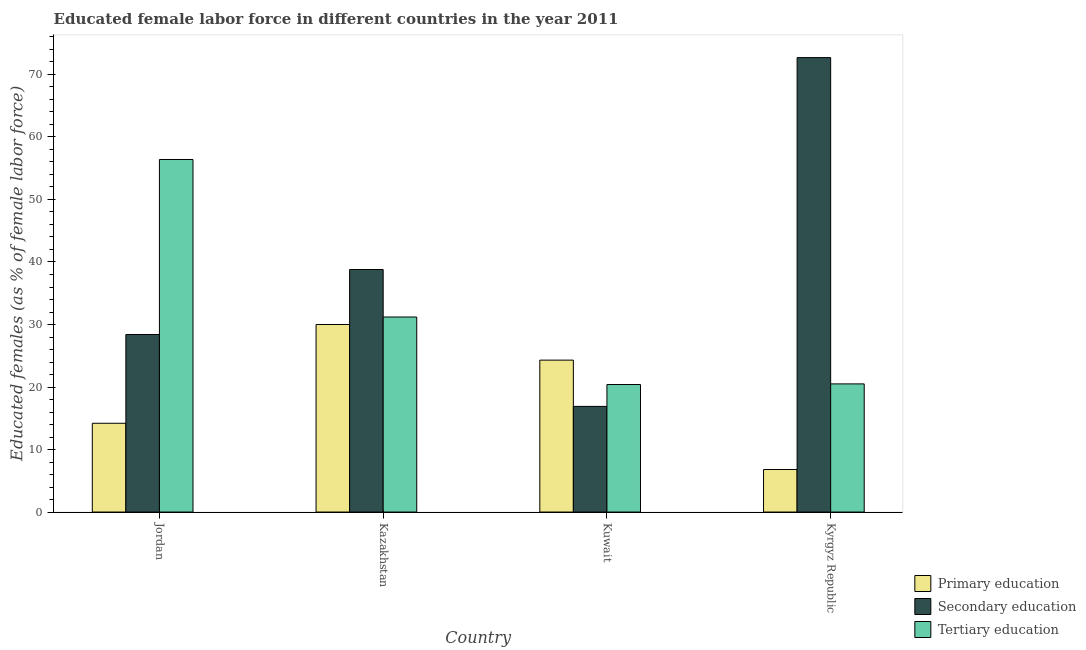How many groups of bars are there?
Keep it short and to the point. 4. Are the number of bars per tick equal to the number of legend labels?
Your answer should be very brief. Yes. How many bars are there on the 3rd tick from the left?
Keep it short and to the point. 3. What is the label of the 3rd group of bars from the left?
Provide a succinct answer. Kuwait. In how many cases, is the number of bars for a given country not equal to the number of legend labels?
Your response must be concise. 0. What is the percentage of female labor force who received secondary education in Kuwait?
Ensure brevity in your answer.  16.9. Across all countries, what is the maximum percentage of female labor force who received tertiary education?
Offer a very short reply. 56.4. Across all countries, what is the minimum percentage of female labor force who received secondary education?
Your answer should be compact. 16.9. In which country was the percentage of female labor force who received primary education maximum?
Provide a succinct answer. Kazakhstan. In which country was the percentage of female labor force who received secondary education minimum?
Offer a terse response. Kuwait. What is the total percentage of female labor force who received primary education in the graph?
Ensure brevity in your answer.  75.3. What is the difference between the percentage of female labor force who received tertiary education in Kazakhstan and that in Kyrgyz Republic?
Give a very brief answer. 10.7. What is the difference between the percentage of female labor force who received secondary education in Kyrgyz Republic and the percentage of female labor force who received tertiary education in Jordan?
Offer a terse response. 16.3. What is the average percentage of female labor force who received tertiary education per country?
Provide a short and direct response. 32.13. What is the difference between the percentage of female labor force who received primary education and percentage of female labor force who received tertiary education in Kuwait?
Provide a short and direct response. 3.9. What is the ratio of the percentage of female labor force who received primary education in Kuwait to that in Kyrgyz Republic?
Make the answer very short. 3.57. Is the percentage of female labor force who received primary education in Kuwait less than that in Kyrgyz Republic?
Ensure brevity in your answer.  No. What is the difference between the highest and the second highest percentage of female labor force who received secondary education?
Your response must be concise. 33.9. What is the difference between the highest and the lowest percentage of female labor force who received primary education?
Make the answer very short. 23.2. What does the 2nd bar from the left in Kyrgyz Republic represents?
Make the answer very short. Secondary education. What does the 2nd bar from the right in Kyrgyz Republic represents?
Offer a terse response. Secondary education. What is the difference between two consecutive major ticks on the Y-axis?
Give a very brief answer. 10. Are the values on the major ticks of Y-axis written in scientific E-notation?
Provide a succinct answer. No. Does the graph contain any zero values?
Your response must be concise. No. Where does the legend appear in the graph?
Provide a succinct answer. Bottom right. How many legend labels are there?
Keep it short and to the point. 3. What is the title of the graph?
Provide a succinct answer. Educated female labor force in different countries in the year 2011. What is the label or title of the X-axis?
Keep it short and to the point. Country. What is the label or title of the Y-axis?
Give a very brief answer. Educated females (as % of female labor force). What is the Educated females (as % of female labor force) of Primary education in Jordan?
Your response must be concise. 14.2. What is the Educated females (as % of female labor force) of Secondary education in Jordan?
Give a very brief answer. 28.4. What is the Educated females (as % of female labor force) of Tertiary education in Jordan?
Provide a short and direct response. 56.4. What is the Educated females (as % of female labor force) of Primary education in Kazakhstan?
Offer a very short reply. 30. What is the Educated females (as % of female labor force) of Secondary education in Kazakhstan?
Ensure brevity in your answer.  38.8. What is the Educated females (as % of female labor force) in Tertiary education in Kazakhstan?
Your response must be concise. 31.2. What is the Educated females (as % of female labor force) in Primary education in Kuwait?
Your response must be concise. 24.3. What is the Educated females (as % of female labor force) in Secondary education in Kuwait?
Make the answer very short. 16.9. What is the Educated females (as % of female labor force) of Tertiary education in Kuwait?
Offer a very short reply. 20.4. What is the Educated females (as % of female labor force) of Primary education in Kyrgyz Republic?
Offer a terse response. 6.8. What is the Educated females (as % of female labor force) in Secondary education in Kyrgyz Republic?
Ensure brevity in your answer.  72.7. Across all countries, what is the maximum Educated females (as % of female labor force) of Primary education?
Give a very brief answer. 30. Across all countries, what is the maximum Educated females (as % of female labor force) of Secondary education?
Your answer should be compact. 72.7. Across all countries, what is the maximum Educated females (as % of female labor force) in Tertiary education?
Ensure brevity in your answer.  56.4. Across all countries, what is the minimum Educated females (as % of female labor force) of Primary education?
Provide a succinct answer. 6.8. Across all countries, what is the minimum Educated females (as % of female labor force) of Secondary education?
Offer a terse response. 16.9. Across all countries, what is the minimum Educated females (as % of female labor force) in Tertiary education?
Your response must be concise. 20.4. What is the total Educated females (as % of female labor force) in Primary education in the graph?
Provide a succinct answer. 75.3. What is the total Educated females (as % of female labor force) in Secondary education in the graph?
Give a very brief answer. 156.8. What is the total Educated females (as % of female labor force) in Tertiary education in the graph?
Your answer should be very brief. 128.5. What is the difference between the Educated females (as % of female labor force) of Primary education in Jordan and that in Kazakhstan?
Your answer should be compact. -15.8. What is the difference between the Educated females (as % of female labor force) of Secondary education in Jordan and that in Kazakhstan?
Provide a short and direct response. -10.4. What is the difference between the Educated females (as % of female labor force) in Tertiary education in Jordan and that in Kazakhstan?
Keep it short and to the point. 25.2. What is the difference between the Educated females (as % of female labor force) in Secondary education in Jordan and that in Kyrgyz Republic?
Make the answer very short. -44.3. What is the difference between the Educated females (as % of female labor force) in Tertiary education in Jordan and that in Kyrgyz Republic?
Offer a very short reply. 35.9. What is the difference between the Educated females (as % of female labor force) of Secondary education in Kazakhstan and that in Kuwait?
Provide a short and direct response. 21.9. What is the difference between the Educated females (as % of female labor force) of Tertiary education in Kazakhstan and that in Kuwait?
Offer a very short reply. 10.8. What is the difference between the Educated females (as % of female labor force) in Primary education in Kazakhstan and that in Kyrgyz Republic?
Give a very brief answer. 23.2. What is the difference between the Educated females (as % of female labor force) in Secondary education in Kazakhstan and that in Kyrgyz Republic?
Provide a succinct answer. -33.9. What is the difference between the Educated females (as % of female labor force) in Primary education in Kuwait and that in Kyrgyz Republic?
Your answer should be compact. 17.5. What is the difference between the Educated females (as % of female labor force) in Secondary education in Kuwait and that in Kyrgyz Republic?
Your answer should be very brief. -55.8. What is the difference between the Educated females (as % of female labor force) of Tertiary education in Kuwait and that in Kyrgyz Republic?
Provide a succinct answer. -0.1. What is the difference between the Educated females (as % of female labor force) of Primary education in Jordan and the Educated females (as % of female labor force) of Secondary education in Kazakhstan?
Ensure brevity in your answer.  -24.6. What is the difference between the Educated females (as % of female labor force) of Primary education in Jordan and the Educated females (as % of female labor force) of Tertiary education in Kazakhstan?
Your answer should be very brief. -17. What is the difference between the Educated females (as % of female labor force) of Secondary education in Jordan and the Educated females (as % of female labor force) of Tertiary education in Kazakhstan?
Make the answer very short. -2.8. What is the difference between the Educated females (as % of female labor force) of Primary education in Jordan and the Educated females (as % of female labor force) of Secondary education in Kuwait?
Your response must be concise. -2.7. What is the difference between the Educated females (as % of female labor force) in Primary education in Jordan and the Educated females (as % of female labor force) in Secondary education in Kyrgyz Republic?
Give a very brief answer. -58.5. What is the difference between the Educated females (as % of female labor force) of Primary education in Kazakhstan and the Educated females (as % of female labor force) of Secondary education in Kuwait?
Your answer should be compact. 13.1. What is the difference between the Educated females (as % of female labor force) of Secondary education in Kazakhstan and the Educated females (as % of female labor force) of Tertiary education in Kuwait?
Offer a very short reply. 18.4. What is the difference between the Educated females (as % of female labor force) of Primary education in Kazakhstan and the Educated females (as % of female labor force) of Secondary education in Kyrgyz Republic?
Offer a very short reply. -42.7. What is the difference between the Educated females (as % of female labor force) of Primary education in Kuwait and the Educated females (as % of female labor force) of Secondary education in Kyrgyz Republic?
Your answer should be compact. -48.4. What is the difference between the Educated females (as % of female labor force) of Secondary education in Kuwait and the Educated females (as % of female labor force) of Tertiary education in Kyrgyz Republic?
Offer a terse response. -3.6. What is the average Educated females (as % of female labor force) in Primary education per country?
Offer a very short reply. 18.82. What is the average Educated females (as % of female labor force) in Secondary education per country?
Keep it short and to the point. 39.2. What is the average Educated females (as % of female labor force) in Tertiary education per country?
Provide a succinct answer. 32.12. What is the difference between the Educated females (as % of female labor force) in Primary education and Educated females (as % of female labor force) in Tertiary education in Jordan?
Ensure brevity in your answer.  -42.2. What is the difference between the Educated females (as % of female labor force) of Primary education and Educated females (as % of female labor force) of Secondary education in Kazakhstan?
Give a very brief answer. -8.8. What is the difference between the Educated females (as % of female labor force) in Primary education and Educated females (as % of female labor force) in Tertiary education in Kazakhstan?
Offer a very short reply. -1.2. What is the difference between the Educated females (as % of female labor force) of Secondary education and Educated females (as % of female labor force) of Tertiary education in Kuwait?
Your answer should be compact. -3.5. What is the difference between the Educated females (as % of female labor force) in Primary education and Educated females (as % of female labor force) in Secondary education in Kyrgyz Republic?
Offer a terse response. -65.9. What is the difference between the Educated females (as % of female labor force) in Primary education and Educated females (as % of female labor force) in Tertiary education in Kyrgyz Republic?
Offer a terse response. -13.7. What is the difference between the Educated females (as % of female labor force) in Secondary education and Educated females (as % of female labor force) in Tertiary education in Kyrgyz Republic?
Make the answer very short. 52.2. What is the ratio of the Educated females (as % of female labor force) of Primary education in Jordan to that in Kazakhstan?
Give a very brief answer. 0.47. What is the ratio of the Educated females (as % of female labor force) of Secondary education in Jordan to that in Kazakhstan?
Make the answer very short. 0.73. What is the ratio of the Educated females (as % of female labor force) in Tertiary education in Jordan to that in Kazakhstan?
Keep it short and to the point. 1.81. What is the ratio of the Educated females (as % of female labor force) of Primary education in Jordan to that in Kuwait?
Give a very brief answer. 0.58. What is the ratio of the Educated females (as % of female labor force) in Secondary education in Jordan to that in Kuwait?
Give a very brief answer. 1.68. What is the ratio of the Educated females (as % of female labor force) in Tertiary education in Jordan to that in Kuwait?
Offer a very short reply. 2.76. What is the ratio of the Educated females (as % of female labor force) in Primary education in Jordan to that in Kyrgyz Republic?
Provide a short and direct response. 2.09. What is the ratio of the Educated females (as % of female labor force) in Secondary education in Jordan to that in Kyrgyz Republic?
Offer a terse response. 0.39. What is the ratio of the Educated females (as % of female labor force) of Tertiary education in Jordan to that in Kyrgyz Republic?
Keep it short and to the point. 2.75. What is the ratio of the Educated females (as % of female labor force) of Primary education in Kazakhstan to that in Kuwait?
Keep it short and to the point. 1.23. What is the ratio of the Educated females (as % of female labor force) of Secondary education in Kazakhstan to that in Kuwait?
Make the answer very short. 2.3. What is the ratio of the Educated females (as % of female labor force) in Tertiary education in Kazakhstan to that in Kuwait?
Your response must be concise. 1.53. What is the ratio of the Educated females (as % of female labor force) in Primary education in Kazakhstan to that in Kyrgyz Republic?
Offer a very short reply. 4.41. What is the ratio of the Educated females (as % of female labor force) of Secondary education in Kazakhstan to that in Kyrgyz Republic?
Your answer should be very brief. 0.53. What is the ratio of the Educated females (as % of female labor force) of Tertiary education in Kazakhstan to that in Kyrgyz Republic?
Give a very brief answer. 1.52. What is the ratio of the Educated females (as % of female labor force) of Primary education in Kuwait to that in Kyrgyz Republic?
Your answer should be very brief. 3.57. What is the ratio of the Educated females (as % of female labor force) of Secondary education in Kuwait to that in Kyrgyz Republic?
Your answer should be compact. 0.23. What is the difference between the highest and the second highest Educated females (as % of female labor force) in Secondary education?
Provide a succinct answer. 33.9. What is the difference between the highest and the second highest Educated females (as % of female labor force) of Tertiary education?
Offer a very short reply. 25.2. What is the difference between the highest and the lowest Educated females (as % of female labor force) in Primary education?
Your answer should be compact. 23.2. What is the difference between the highest and the lowest Educated females (as % of female labor force) of Secondary education?
Give a very brief answer. 55.8. What is the difference between the highest and the lowest Educated females (as % of female labor force) in Tertiary education?
Keep it short and to the point. 36. 